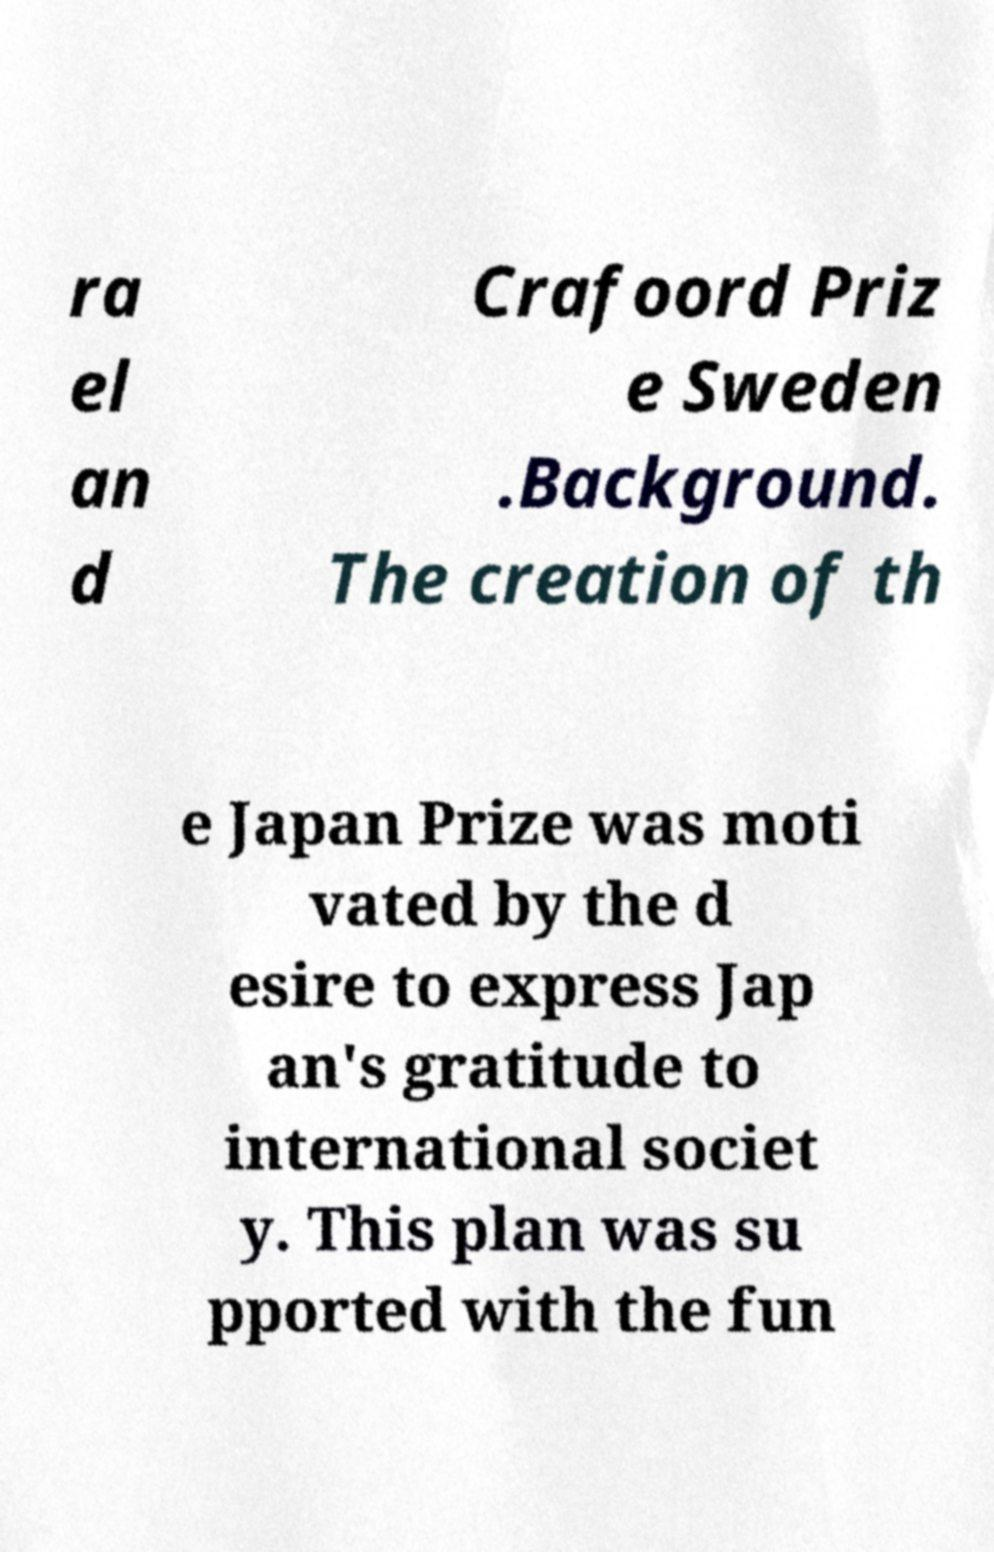For documentation purposes, I need the text within this image transcribed. Could you provide that? ra el an d Crafoord Priz e Sweden .Background. The creation of th e Japan Prize was moti vated by the d esire to express Jap an's gratitude to international societ y. This plan was su pported with the fun 